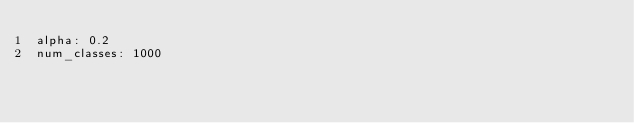<code> <loc_0><loc_0><loc_500><loc_500><_YAML_>alpha: 0.2
num_classes: 1000
</code> 